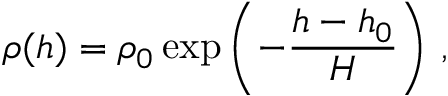<formula> <loc_0><loc_0><loc_500><loc_500>\rho ( h ) = \rho _ { 0 } \exp \left ( - \frac { h - h _ { 0 } } { H } \right ) \, ,</formula> 